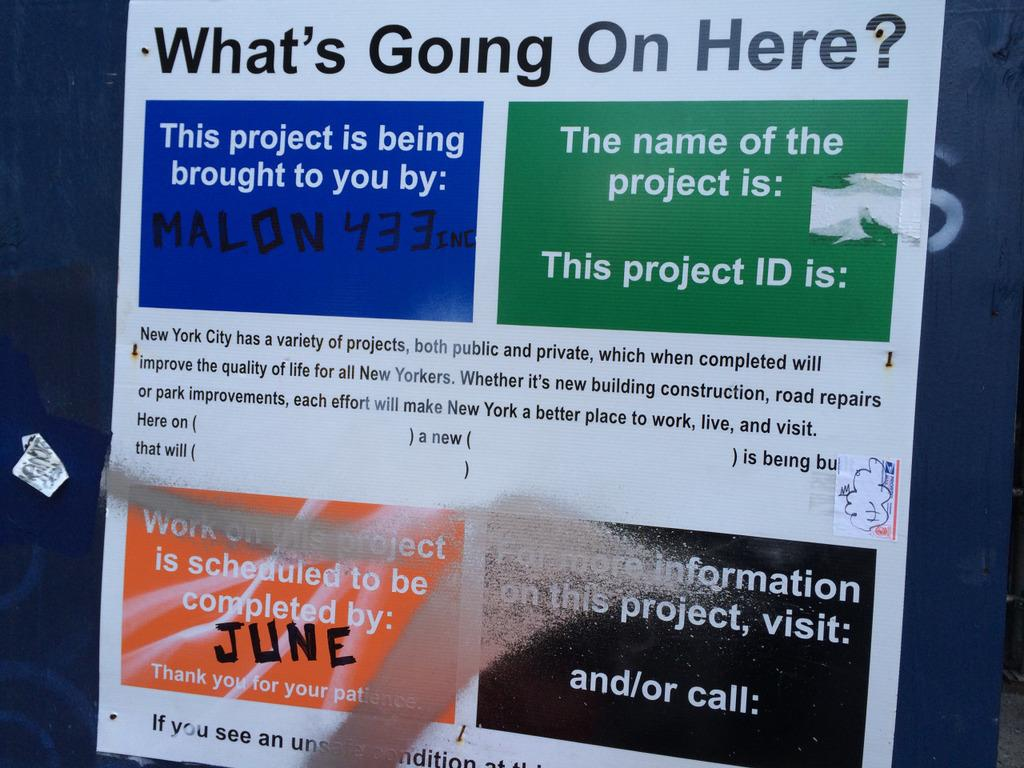<image>
Create a compact narrative representing the image presented. A sign posted for New Yorkers to complete projects that will improve the quality of life for all New Yorkers. 